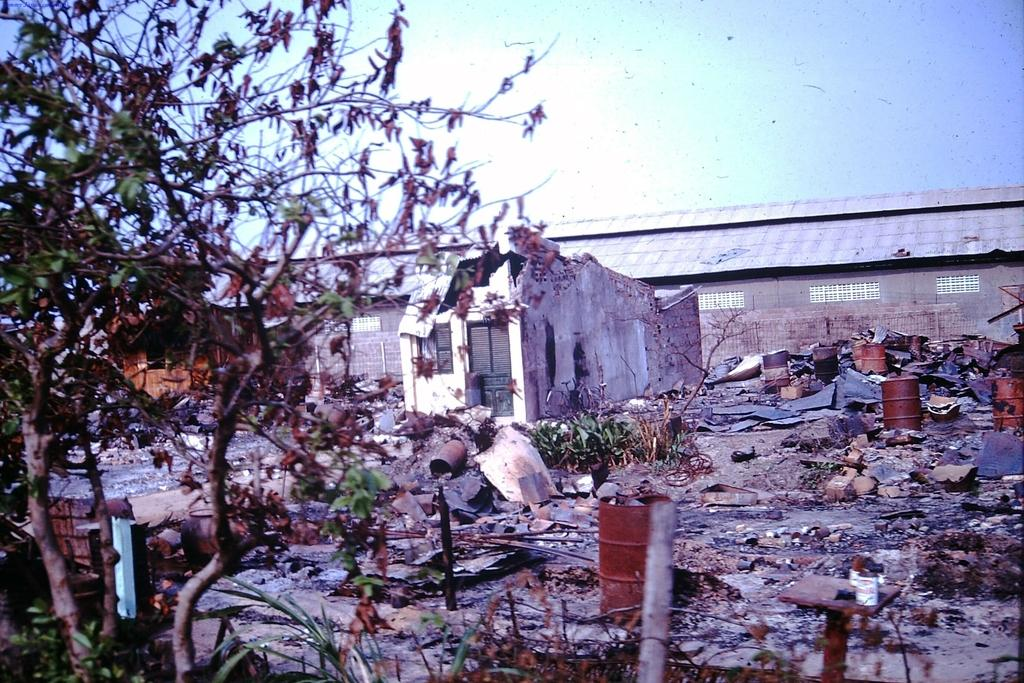What type of structure can be seen on the left side of the image? There is a shed in the image. What other type of structure is present in the image? There is a house in the image. Are there any plants visible in the image? Yes, there is a plant in the image. What else can be seen in the image besides the structures and the plant? There are barrels in the image. Who is the creator of the tax system in the image? There is no reference to a tax system or a creator in the image. 